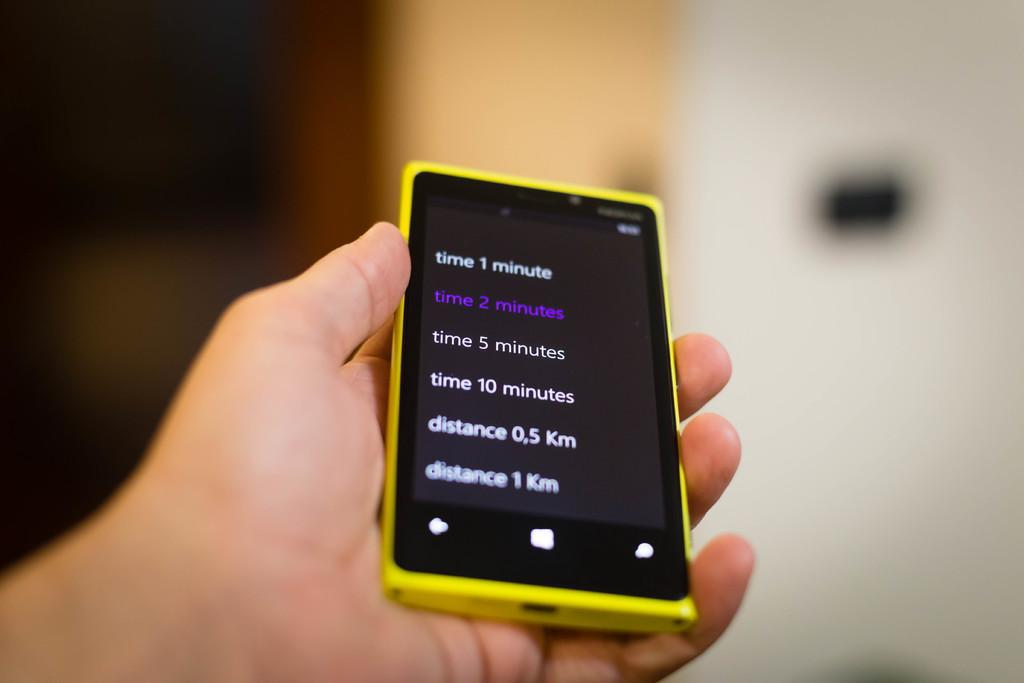<image>
Write a terse but informative summary of the picture. a yellow and black phone that says 'time 2 minutes' in purple on the screen 